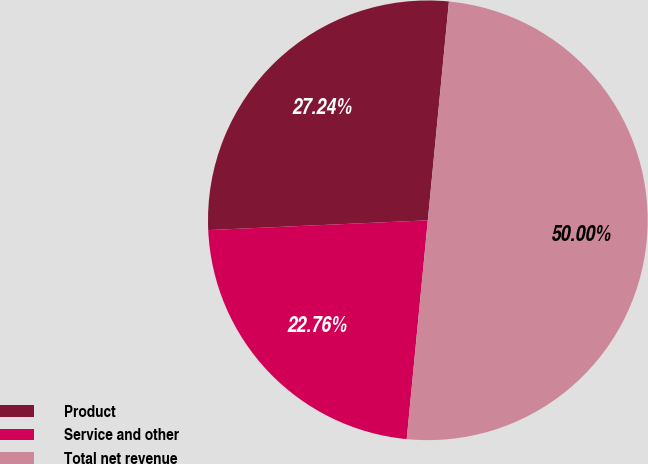Convert chart to OTSL. <chart><loc_0><loc_0><loc_500><loc_500><pie_chart><fcel>Product<fcel>Service and other<fcel>Total net revenue<nl><fcel>27.24%<fcel>22.76%<fcel>50.0%<nl></chart> 